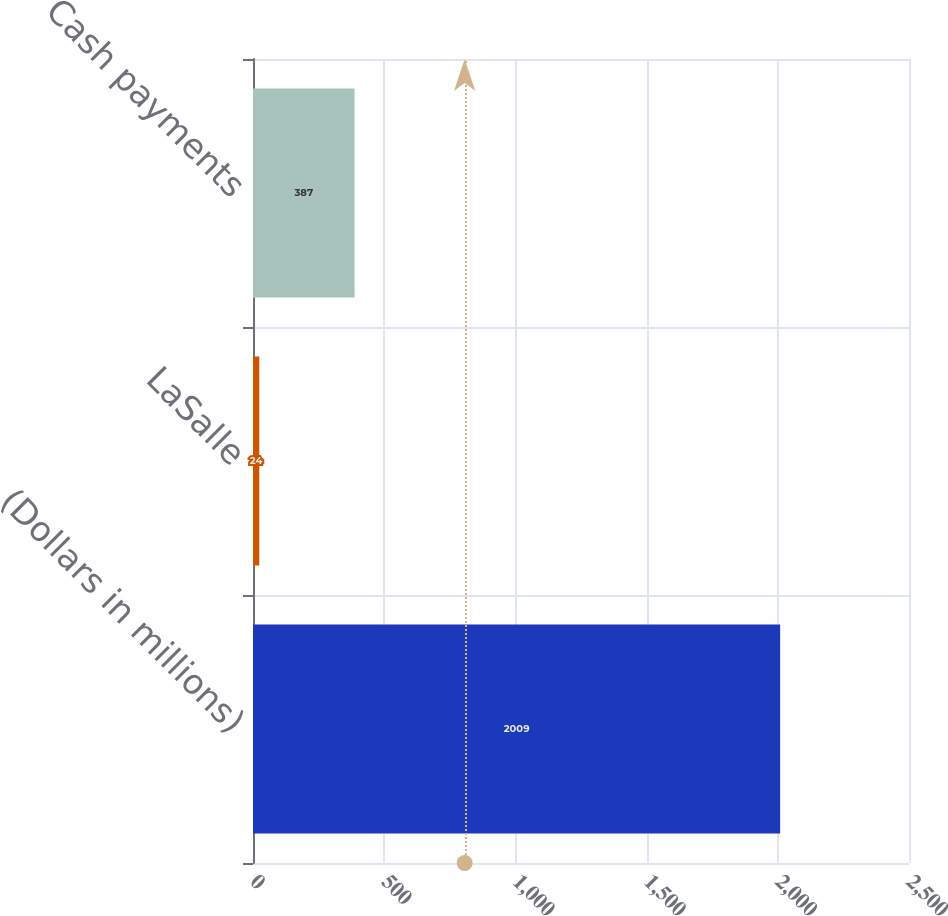Convert chart to OTSL. <chart><loc_0><loc_0><loc_500><loc_500><bar_chart><fcel>(Dollars in millions)<fcel>LaSalle<fcel>Cash payments<nl><fcel>2009<fcel>24<fcel>387<nl></chart> 